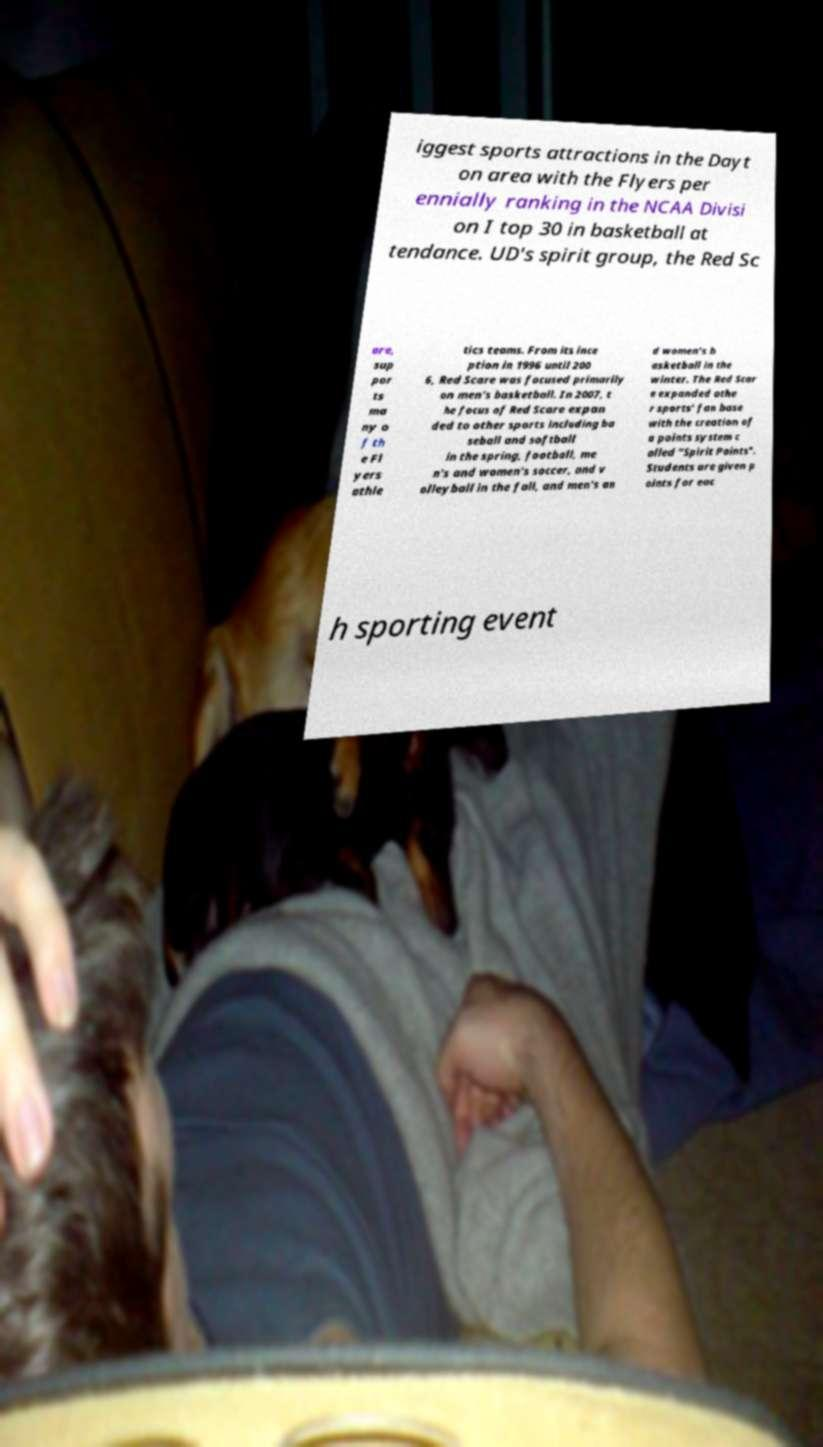There's text embedded in this image that I need extracted. Can you transcribe it verbatim? iggest sports attractions in the Dayt on area with the Flyers per ennially ranking in the NCAA Divisi on I top 30 in basketball at tendance. UD's spirit group, the Red Sc are, sup por ts ma ny o f th e Fl yers athle tics teams. From its ince ption in 1996 until 200 6, Red Scare was focused primarily on men's basketball. In 2007, t he focus of Red Scare expan ded to other sports including ba seball and softball in the spring, football, me n's and women's soccer, and v olleyball in the fall, and men's an d women's b asketball in the winter. The Red Scar e expanded othe r sports' fan base with the creation of a points system c alled "Spirit Points". Students are given p oints for eac h sporting event 